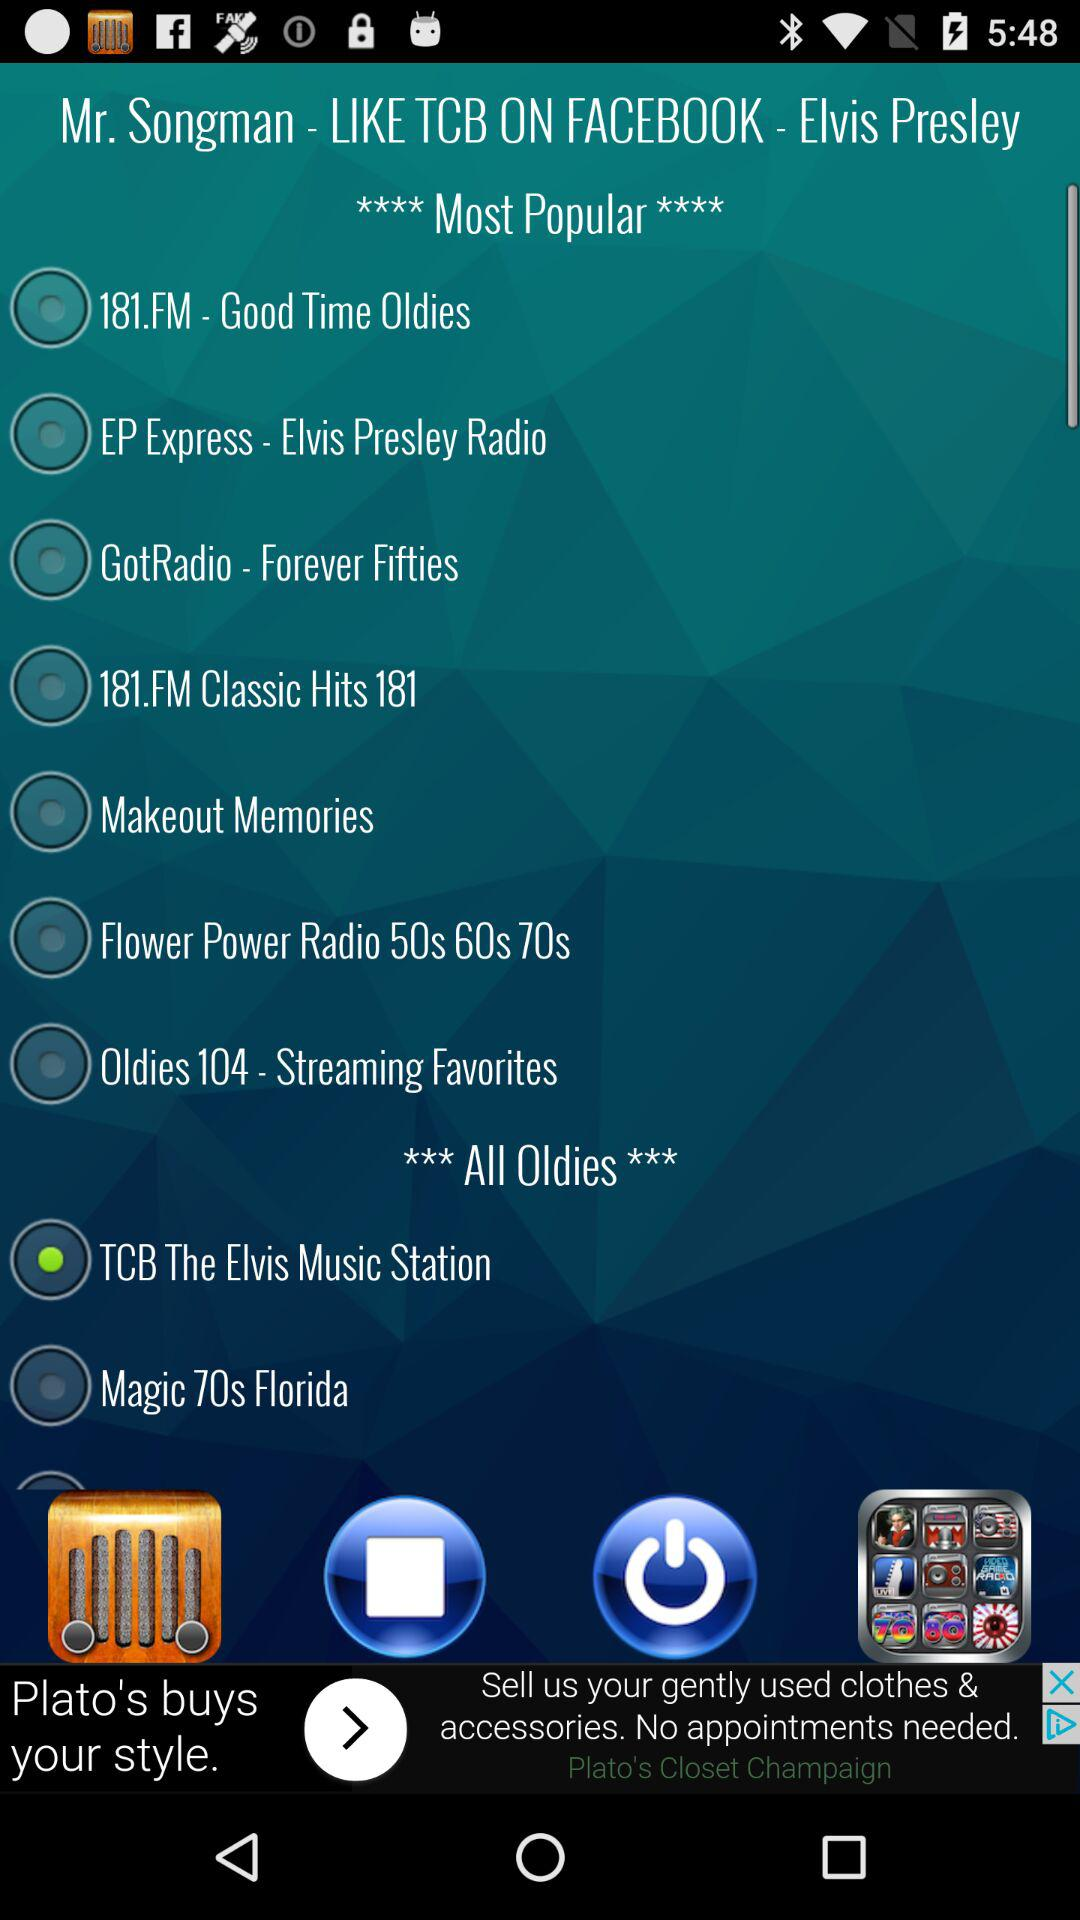What is the selected option? The selected option is "TCB The Elvis Music Station". 